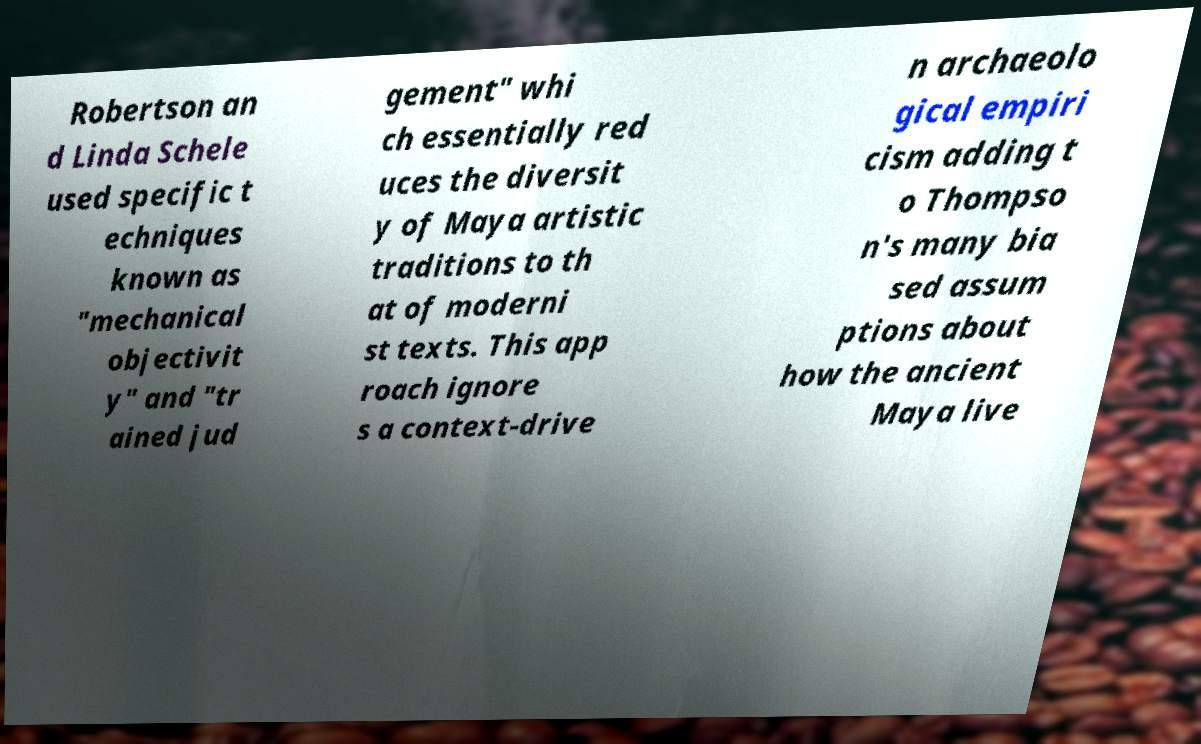For documentation purposes, I need the text within this image transcribed. Could you provide that? Robertson an d Linda Schele used specific t echniques known as "mechanical objectivit y" and "tr ained jud gement" whi ch essentially red uces the diversit y of Maya artistic traditions to th at of moderni st texts. This app roach ignore s a context-drive n archaeolo gical empiri cism adding t o Thompso n's many bia sed assum ptions about how the ancient Maya live 